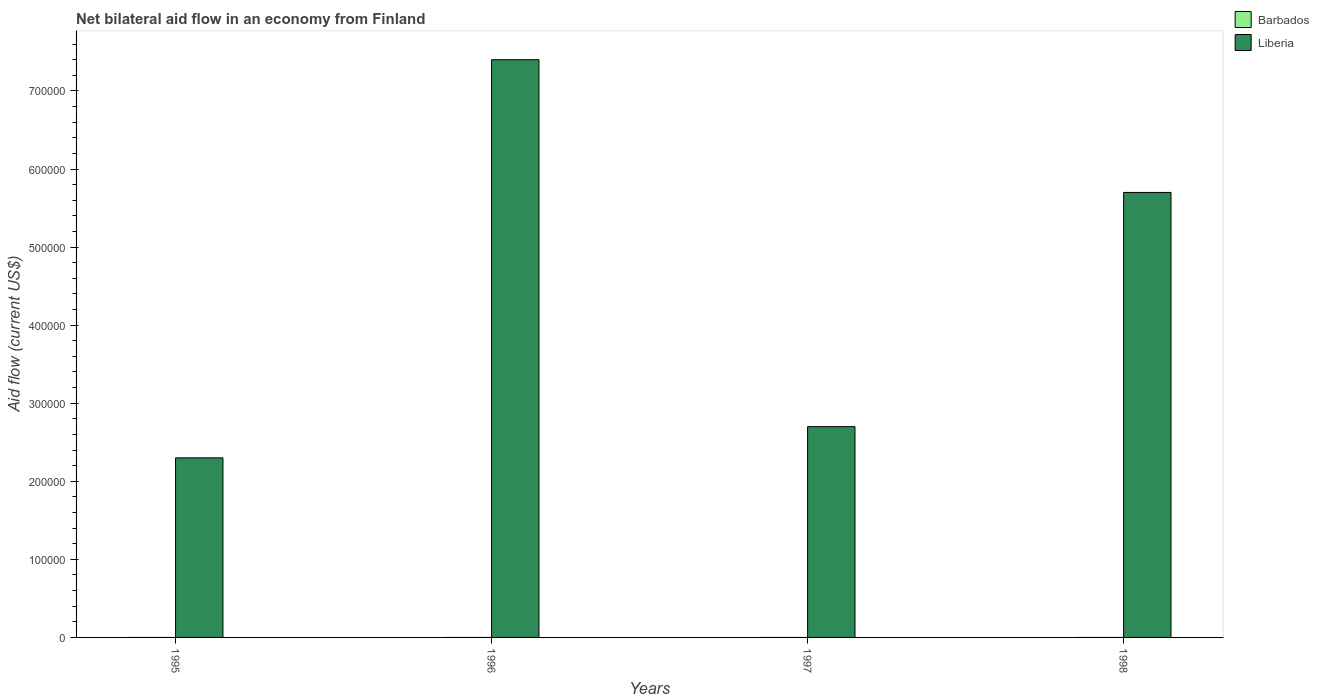How many different coloured bars are there?
Your answer should be compact. 1. Are the number of bars per tick equal to the number of legend labels?
Provide a short and direct response. No. How many bars are there on the 1st tick from the left?
Provide a short and direct response. 1. What is the label of the 1st group of bars from the left?
Offer a very short reply. 1995. Across all years, what is the maximum net bilateral aid flow in Liberia?
Keep it short and to the point. 7.40e+05. In which year was the net bilateral aid flow in Liberia maximum?
Provide a succinct answer. 1996. What is the difference between the net bilateral aid flow in Liberia in 1996 and that in 1997?
Your response must be concise. 4.70e+05. What is the difference between the net bilateral aid flow in Liberia in 1997 and the net bilateral aid flow in Barbados in 1995?
Your response must be concise. 2.70e+05. What is the average net bilateral aid flow in Liberia per year?
Your answer should be very brief. 4.52e+05. In how many years, is the net bilateral aid flow in Barbados greater than 160000 US$?
Make the answer very short. 0. What is the ratio of the net bilateral aid flow in Liberia in 1995 to that in 1998?
Offer a terse response. 0.4. What is the difference between the highest and the lowest net bilateral aid flow in Liberia?
Give a very brief answer. 5.10e+05. How many years are there in the graph?
Keep it short and to the point. 4. Are the values on the major ticks of Y-axis written in scientific E-notation?
Offer a terse response. No. Does the graph contain any zero values?
Provide a succinct answer. Yes. Where does the legend appear in the graph?
Your answer should be compact. Top right. How many legend labels are there?
Offer a terse response. 2. What is the title of the graph?
Your answer should be compact. Net bilateral aid flow in an economy from Finland. Does "Arab World" appear as one of the legend labels in the graph?
Give a very brief answer. No. What is the label or title of the X-axis?
Your answer should be compact. Years. What is the label or title of the Y-axis?
Give a very brief answer. Aid flow (current US$). What is the Aid flow (current US$) of Liberia in 1995?
Provide a succinct answer. 2.30e+05. What is the Aid flow (current US$) in Barbados in 1996?
Your response must be concise. 0. What is the Aid flow (current US$) of Liberia in 1996?
Keep it short and to the point. 7.40e+05. What is the Aid flow (current US$) of Barbados in 1997?
Keep it short and to the point. 0. What is the Aid flow (current US$) in Liberia in 1997?
Provide a short and direct response. 2.70e+05. What is the Aid flow (current US$) in Liberia in 1998?
Give a very brief answer. 5.70e+05. Across all years, what is the maximum Aid flow (current US$) of Liberia?
Keep it short and to the point. 7.40e+05. What is the total Aid flow (current US$) of Liberia in the graph?
Give a very brief answer. 1.81e+06. What is the difference between the Aid flow (current US$) in Liberia in 1995 and that in 1996?
Your response must be concise. -5.10e+05. What is the difference between the Aid flow (current US$) of Liberia in 1995 and that in 1998?
Provide a succinct answer. -3.40e+05. What is the difference between the Aid flow (current US$) in Liberia in 1996 and that in 1997?
Your answer should be compact. 4.70e+05. What is the difference between the Aid flow (current US$) of Liberia in 1996 and that in 1998?
Give a very brief answer. 1.70e+05. What is the difference between the Aid flow (current US$) of Liberia in 1997 and that in 1998?
Offer a very short reply. -3.00e+05. What is the average Aid flow (current US$) in Liberia per year?
Offer a terse response. 4.52e+05. What is the ratio of the Aid flow (current US$) of Liberia in 1995 to that in 1996?
Your response must be concise. 0.31. What is the ratio of the Aid flow (current US$) of Liberia in 1995 to that in 1997?
Offer a terse response. 0.85. What is the ratio of the Aid flow (current US$) in Liberia in 1995 to that in 1998?
Your response must be concise. 0.4. What is the ratio of the Aid flow (current US$) of Liberia in 1996 to that in 1997?
Your answer should be compact. 2.74. What is the ratio of the Aid flow (current US$) of Liberia in 1996 to that in 1998?
Offer a terse response. 1.3. What is the ratio of the Aid flow (current US$) of Liberia in 1997 to that in 1998?
Give a very brief answer. 0.47. What is the difference between the highest and the second highest Aid flow (current US$) in Liberia?
Provide a short and direct response. 1.70e+05. What is the difference between the highest and the lowest Aid flow (current US$) of Liberia?
Offer a terse response. 5.10e+05. 